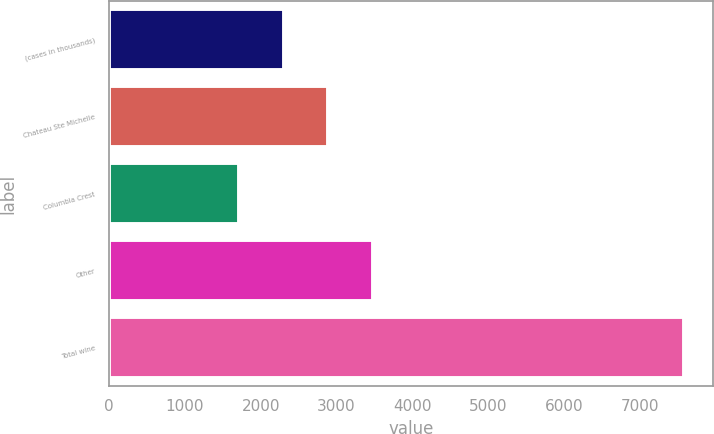<chart> <loc_0><loc_0><loc_500><loc_500><bar_chart><fcel>(cases in thousands)<fcel>Chateau Ste Michelle<fcel>Columbia Crest<fcel>Other<fcel>Total wine<nl><fcel>2303.3<fcel>2890.6<fcel>1716<fcel>3477.9<fcel>7589<nl></chart> 